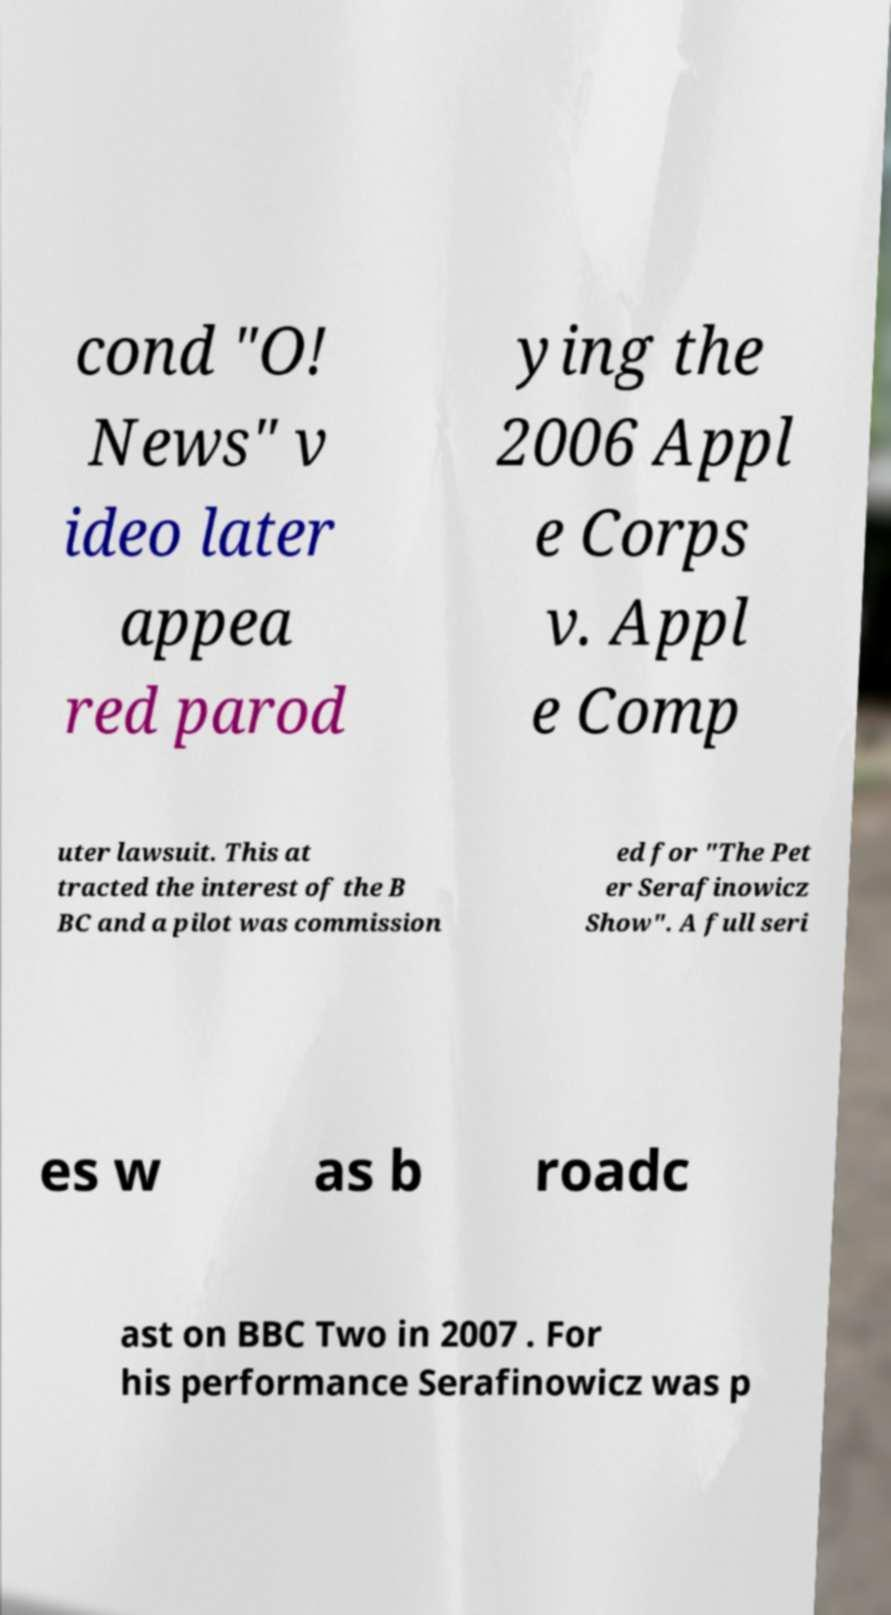Can you accurately transcribe the text from the provided image for me? cond "O! News" v ideo later appea red parod ying the 2006 Appl e Corps v. Appl e Comp uter lawsuit. This at tracted the interest of the B BC and a pilot was commission ed for "The Pet er Serafinowicz Show". A full seri es w as b roadc ast on BBC Two in 2007 . For his performance Serafinowicz was p 